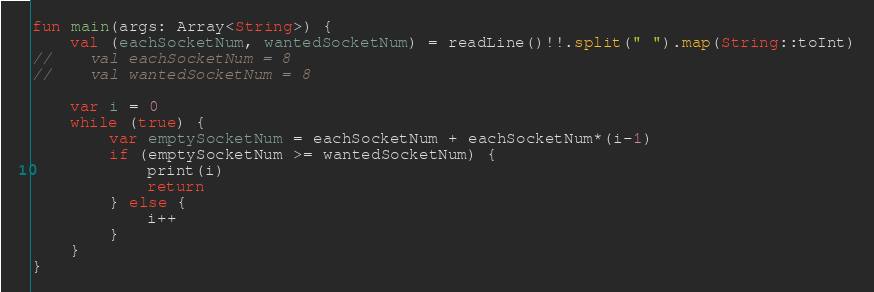<code> <loc_0><loc_0><loc_500><loc_500><_Kotlin_>fun main(args: Array<String>) {
    val (eachSocketNum, wantedSocketNum) = readLine()!!.split(" ").map(String::toInt)
//    val eachSocketNum = 8
//    val wantedSocketNum = 8
    
    var i = 0
    while (true) {
        var emptySocketNum = eachSocketNum + eachSocketNum*(i-1)
        if (emptySocketNum >= wantedSocketNum) {
            print(i)
            return
        } else {
            i++
        }
    }
}</code> 